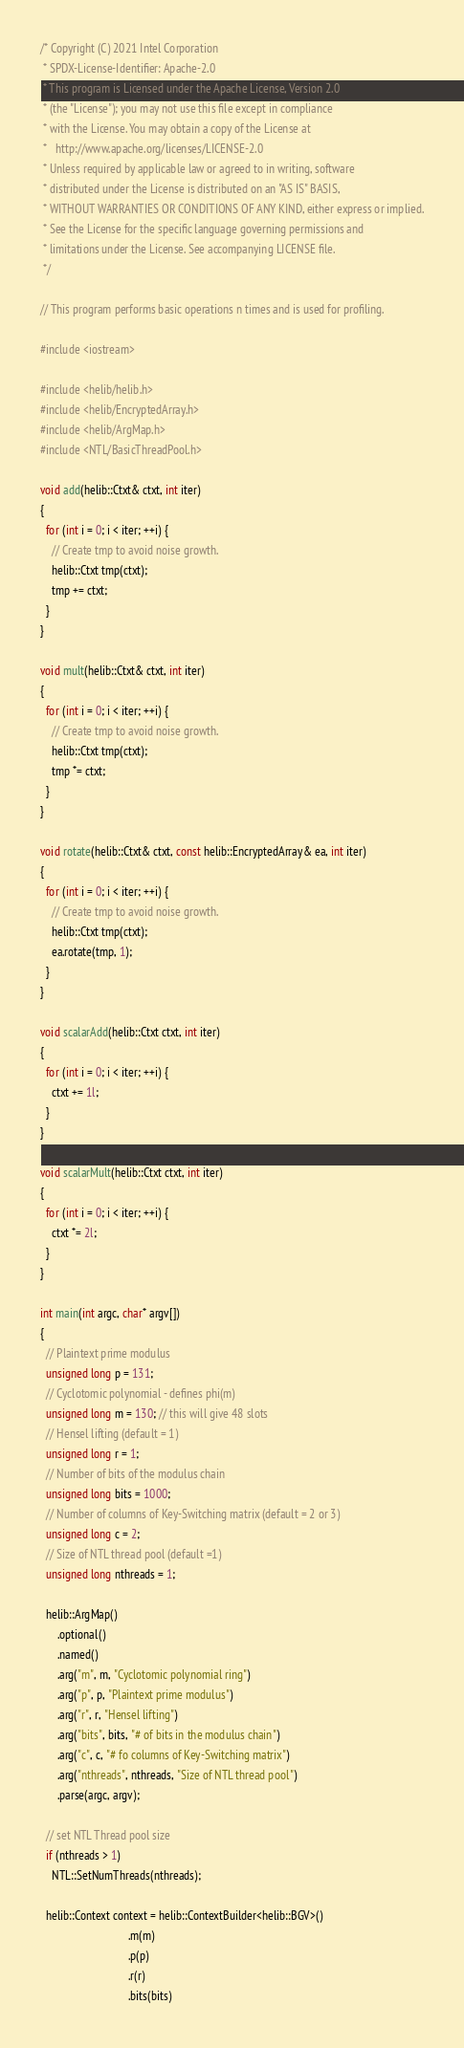Convert code to text. <code><loc_0><loc_0><loc_500><loc_500><_C++_>/* Copyright (C) 2021 Intel Corporation
 * SPDX-License-Identifier: Apache-2.0
 * This program is Licensed under the Apache License, Version 2.0
 * (the "License"); you may not use this file except in compliance
 * with the License. You may obtain a copy of the License at
 *   http://www.apache.org/licenses/LICENSE-2.0
 * Unless required by applicable law or agreed to in writing, software
 * distributed under the License is distributed on an "AS IS" BASIS,
 * WITHOUT WARRANTIES OR CONDITIONS OF ANY KIND, either express or implied.
 * See the License for the specific language governing permissions and
 * limitations under the License. See accompanying LICENSE file.
 */

// This program performs basic operations n times and is used for profiling.

#include <iostream>

#include <helib/helib.h>
#include <helib/EncryptedArray.h>
#include <helib/ArgMap.h>
#include <NTL/BasicThreadPool.h>

void add(helib::Ctxt& ctxt, int iter)
{
  for (int i = 0; i < iter; ++i) {
    // Create tmp to avoid noise growth.
    helib::Ctxt tmp(ctxt);
    tmp += ctxt;
  }
}

void mult(helib::Ctxt& ctxt, int iter)
{
  for (int i = 0; i < iter; ++i) {
    // Create tmp to avoid noise growth.
    helib::Ctxt tmp(ctxt);
    tmp *= ctxt;
  }
}

void rotate(helib::Ctxt& ctxt, const helib::EncryptedArray& ea, int iter)
{
  for (int i = 0; i < iter; ++i) {
    // Create tmp to avoid noise growth.
    helib::Ctxt tmp(ctxt);
    ea.rotate(tmp, 1);
  }
}

void scalarAdd(helib::Ctxt ctxt, int iter)
{
  for (int i = 0; i < iter; ++i) {
    ctxt += 1l;
  }
}

void scalarMult(helib::Ctxt ctxt, int iter)
{
  for (int i = 0; i < iter; ++i) {
    ctxt *= 2l;
  }
}

int main(int argc, char* argv[])
{
  // Plaintext prime modulus
  unsigned long p = 131;
  // Cyclotomic polynomial - defines phi(m)
  unsigned long m = 130; // this will give 48 slots
  // Hensel lifting (default = 1)
  unsigned long r = 1;
  // Number of bits of the modulus chain
  unsigned long bits = 1000;
  // Number of columns of Key-Switching matrix (default = 2 or 3)
  unsigned long c = 2;
  // Size of NTL thread pool (default =1)
  unsigned long nthreads = 1;

  helib::ArgMap()
      .optional()
      .named()
      .arg("m", m, "Cyclotomic polynomial ring")
      .arg("p", p, "Plaintext prime modulus")
      .arg("r", r, "Hensel lifting")
      .arg("bits", bits, "# of bits in the modulus chain")
      .arg("c", c, "# fo columns of Key-Switching matrix")
      .arg("nthreads", nthreads, "Size of NTL thread pool")
      .parse(argc, argv);

  // set NTL Thread pool size
  if (nthreads > 1)
    NTL::SetNumThreads(nthreads);

  helib::Context context = helib::ContextBuilder<helib::BGV>()
                               .m(m)
                               .p(p)
                               .r(r)
                               .bits(bits)</code> 